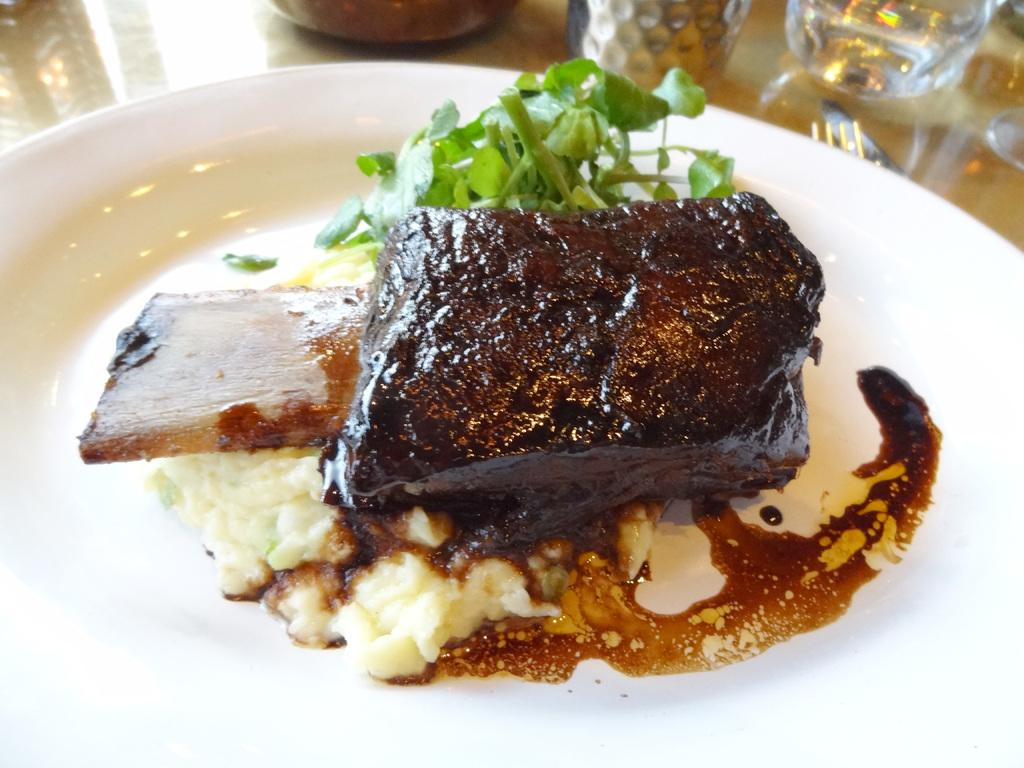What is the main subject in the foreground of the image? There is food in the foreground of the image. Can you describe the type of food on the white platter? The white platter contains leafy vegetables. What can be seen at the top of the image? There are glasses at the top of the image. What utensils are present in the image? There is a fork and a knife in the image. What object is on the surface at the top of the image? There is an object on the surface at the top of the image, but the specific details are not provided. What type of watch is visible on the leafy vegetables in the image? There is no watch present on the leafy vegetables in the image. 